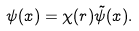<formula> <loc_0><loc_0><loc_500><loc_500>\psi ( x ) = \chi ( r ) \tilde { \psi } ( x ) .</formula> 